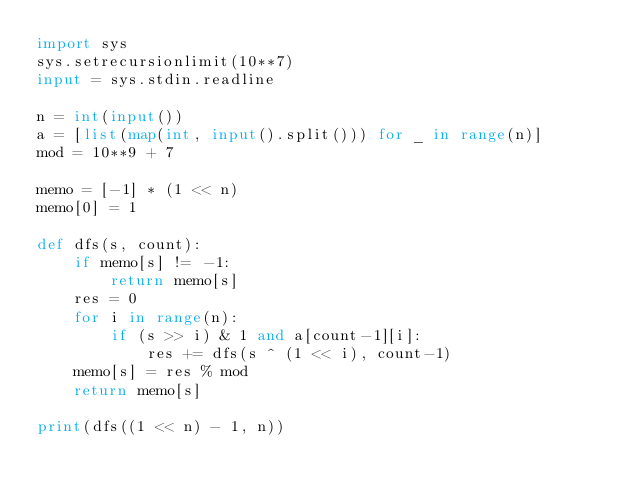Convert code to text. <code><loc_0><loc_0><loc_500><loc_500><_Python_>import sys
sys.setrecursionlimit(10**7)
input = sys.stdin.readline

n = int(input())
a = [list(map(int, input().split())) for _ in range(n)]
mod = 10**9 + 7

memo = [-1] * (1 << n)
memo[0] = 1

def dfs(s, count):
    if memo[s] != -1:
        return memo[s]
    res = 0
    for i in range(n):
        if (s >> i) & 1 and a[count-1][i]:
            res += dfs(s ^ (1 << i), count-1)
    memo[s] = res % mod
    return memo[s]

print(dfs((1 << n) - 1, n))

</code> 